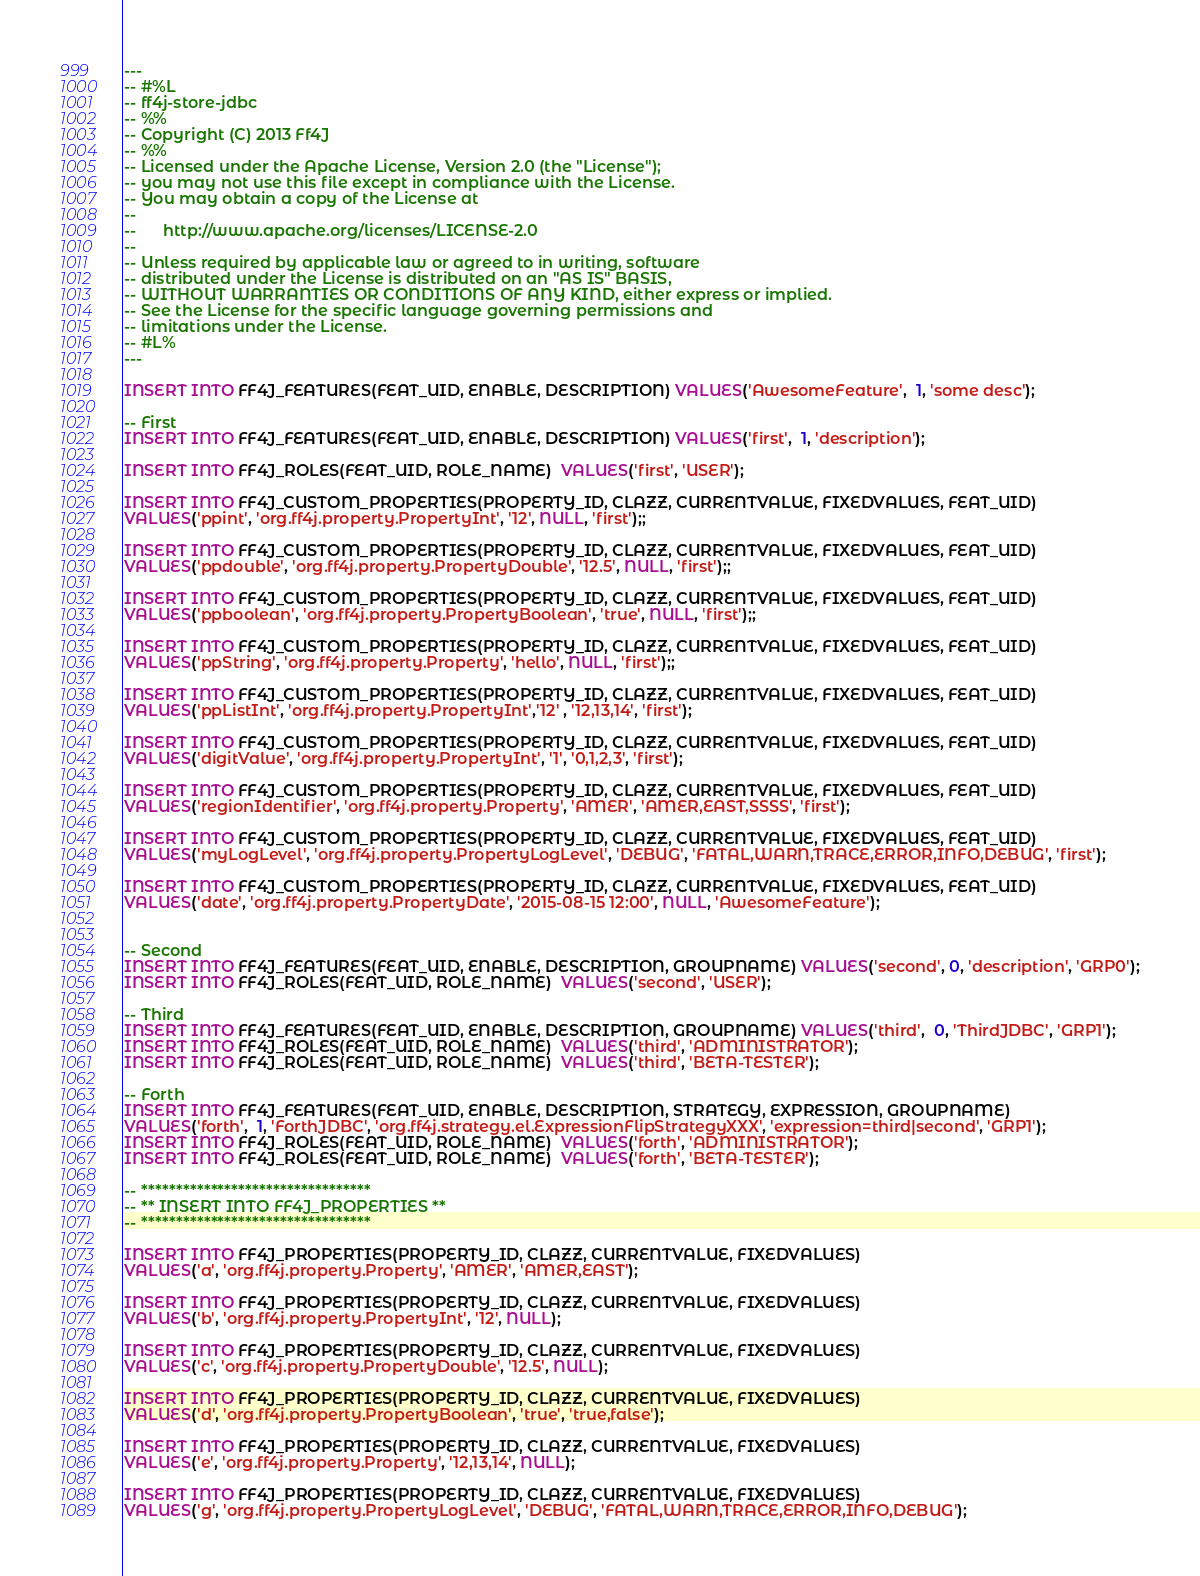<code> <loc_0><loc_0><loc_500><loc_500><_SQL_>---
-- #%L
-- ff4j-store-jdbc
-- %%
-- Copyright (C) 2013 Ff4J
-- %%
-- Licensed under the Apache License, Version 2.0 (the "License");
-- you may not use this file except in compliance with the License.
-- You may obtain a copy of the License at
-- 
--      http://www.apache.org/licenses/LICENSE-2.0
-- 
-- Unless required by applicable law or agreed to in writing, software
-- distributed under the License is distributed on an "AS IS" BASIS,
-- WITHOUT WARRANTIES OR CONDITIONS OF ANY KIND, either express or implied.
-- See the License for the specific language governing permissions and
-- limitations under the License.
-- #L%
---

INSERT INTO FF4J_FEATURES(FEAT_UID, ENABLE, DESCRIPTION) VALUES('AwesomeFeature',  1, 'some desc');

-- First
INSERT INTO FF4J_FEATURES(FEAT_UID, ENABLE, DESCRIPTION) VALUES('first',  1, 'description');

INSERT INTO FF4J_ROLES(FEAT_UID, ROLE_NAME)  VALUES('first', 'USER');

INSERT INTO FF4J_CUSTOM_PROPERTIES(PROPERTY_ID, CLAZZ, CURRENTVALUE, FIXEDVALUES, FEAT_UID) 
VALUES('ppint', 'org.ff4j.property.PropertyInt', '12', NULL, 'first');;

INSERT INTO FF4J_CUSTOM_PROPERTIES(PROPERTY_ID, CLAZZ, CURRENTVALUE, FIXEDVALUES, FEAT_UID) 
VALUES('ppdouble', 'org.ff4j.property.PropertyDouble', '12.5', NULL, 'first');;

INSERT INTO FF4J_CUSTOM_PROPERTIES(PROPERTY_ID, CLAZZ, CURRENTVALUE, FIXEDVALUES, FEAT_UID) 
VALUES('ppboolean', 'org.ff4j.property.PropertyBoolean', 'true', NULL, 'first');;

INSERT INTO FF4J_CUSTOM_PROPERTIES(PROPERTY_ID, CLAZZ, CURRENTVALUE, FIXEDVALUES, FEAT_UID) 
VALUES('ppString', 'org.ff4j.property.Property', 'hello', NULL, 'first');;

INSERT INTO FF4J_CUSTOM_PROPERTIES(PROPERTY_ID, CLAZZ, CURRENTVALUE, FIXEDVALUES, FEAT_UID) 
VALUES('ppListInt', 'org.ff4j.property.PropertyInt','12' , '12,13,14', 'first');

INSERT INTO FF4J_CUSTOM_PROPERTIES(PROPERTY_ID, CLAZZ, CURRENTVALUE, FIXEDVALUES, FEAT_UID) 
VALUES('digitValue', 'org.ff4j.property.PropertyInt', '1', '0,1,2,3', 'first');

INSERT INTO FF4J_CUSTOM_PROPERTIES(PROPERTY_ID, CLAZZ, CURRENTVALUE, FIXEDVALUES, FEAT_UID) 
VALUES('regionIdentifier', 'org.ff4j.property.Property', 'AMER', 'AMER,EAST,SSSS', 'first');

INSERT INTO FF4J_CUSTOM_PROPERTIES(PROPERTY_ID, CLAZZ, CURRENTVALUE, FIXEDVALUES, FEAT_UID) 
VALUES('myLogLevel', 'org.ff4j.property.PropertyLogLevel', 'DEBUG', 'FATAL,WARN,TRACE,ERROR,INFO,DEBUG', 'first');

INSERT INTO FF4J_CUSTOM_PROPERTIES(PROPERTY_ID, CLAZZ, CURRENTVALUE, FIXEDVALUES, FEAT_UID) 
VALUES('date', 'org.ff4j.property.PropertyDate', '2015-08-15 12:00', NULL, 'AwesomeFeature');


-- Second
INSERT INTO FF4J_FEATURES(FEAT_UID, ENABLE, DESCRIPTION, GROUPNAME) VALUES('second', 0, 'description', 'GRP0');
INSERT INTO FF4J_ROLES(FEAT_UID, ROLE_NAME)  VALUES('second', 'USER');

-- Third
INSERT INTO FF4J_FEATURES(FEAT_UID, ENABLE, DESCRIPTION, GROUPNAME) VALUES('third',  0, 'ThirdJDBC', 'GRP1');
INSERT INTO FF4J_ROLES(FEAT_UID, ROLE_NAME)  VALUES('third', 'ADMINISTRATOR');
INSERT INTO FF4J_ROLES(FEAT_UID, ROLE_NAME)  VALUES('third', 'BETA-TESTER');

-- Forth
INSERT INTO FF4J_FEATURES(FEAT_UID, ENABLE, DESCRIPTION, STRATEGY, EXPRESSION, GROUPNAME) 
VALUES('forth',  1, 'ForthJDBC', 'org.ff4j.strategy.el.ExpressionFlipStrategyXXX', 'expression=third|second', 'GRP1');
INSERT INTO FF4J_ROLES(FEAT_UID, ROLE_NAME)  VALUES('forth', 'ADMINISTRATOR');
INSERT INTO FF4J_ROLES(FEAT_UID, ROLE_NAME)  VALUES('forth', 'BETA-TESTER');

-- *********************************
-- ** INSERT INTO FF4J_PROPERTIES ** 
-- *********************************

INSERT INTO FF4J_PROPERTIES(PROPERTY_ID, CLAZZ, CURRENTVALUE, FIXEDVALUES) 
VALUES('a', 'org.ff4j.property.Property', 'AMER', 'AMER,EAST');

INSERT INTO FF4J_PROPERTIES(PROPERTY_ID, CLAZZ, CURRENTVALUE, FIXEDVALUES) 
VALUES('b', 'org.ff4j.property.PropertyInt', '12', NULL);

INSERT INTO FF4J_PROPERTIES(PROPERTY_ID, CLAZZ, CURRENTVALUE, FIXEDVALUES) 
VALUES('c', 'org.ff4j.property.PropertyDouble', '12.5', NULL);

INSERT INTO FF4J_PROPERTIES(PROPERTY_ID, CLAZZ, CURRENTVALUE, FIXEDVALUES) 
VALUES('d', 'org.ff4j.property.PropertyBoolean', 'true', 'true,false');

INSERT INTO FF4J_PROPERTIES(PROPERTY_ID, CLAZZ, CURRENTVALUE, FIXEDVALUES) 
VALUES('e', 'org.ff4j.property.Property', '12,13,14', NULL);

INSERT INTO FF4J_PROPERTIES(PROPERTY_ID, CLAZZ, CURRENTVALUE, FIXEDVALUES) 
VALUES('g', 'org.ff4j.property.PropertyLogLevel', 'DEBUG', 'FATAL,WARN,TRACE,ERROR,INFO,DEBUG');

</code> 